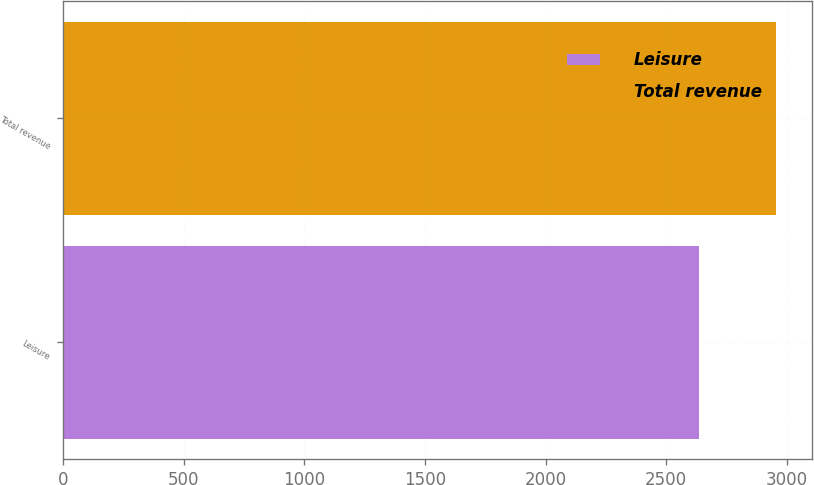<chart> <loc_0><loc_0><loc_500><loc_500><bar_chart><fcel>Leisure<fcel>Total revenue<nl><fcel>2635<fcel>2955<nl></chart> 